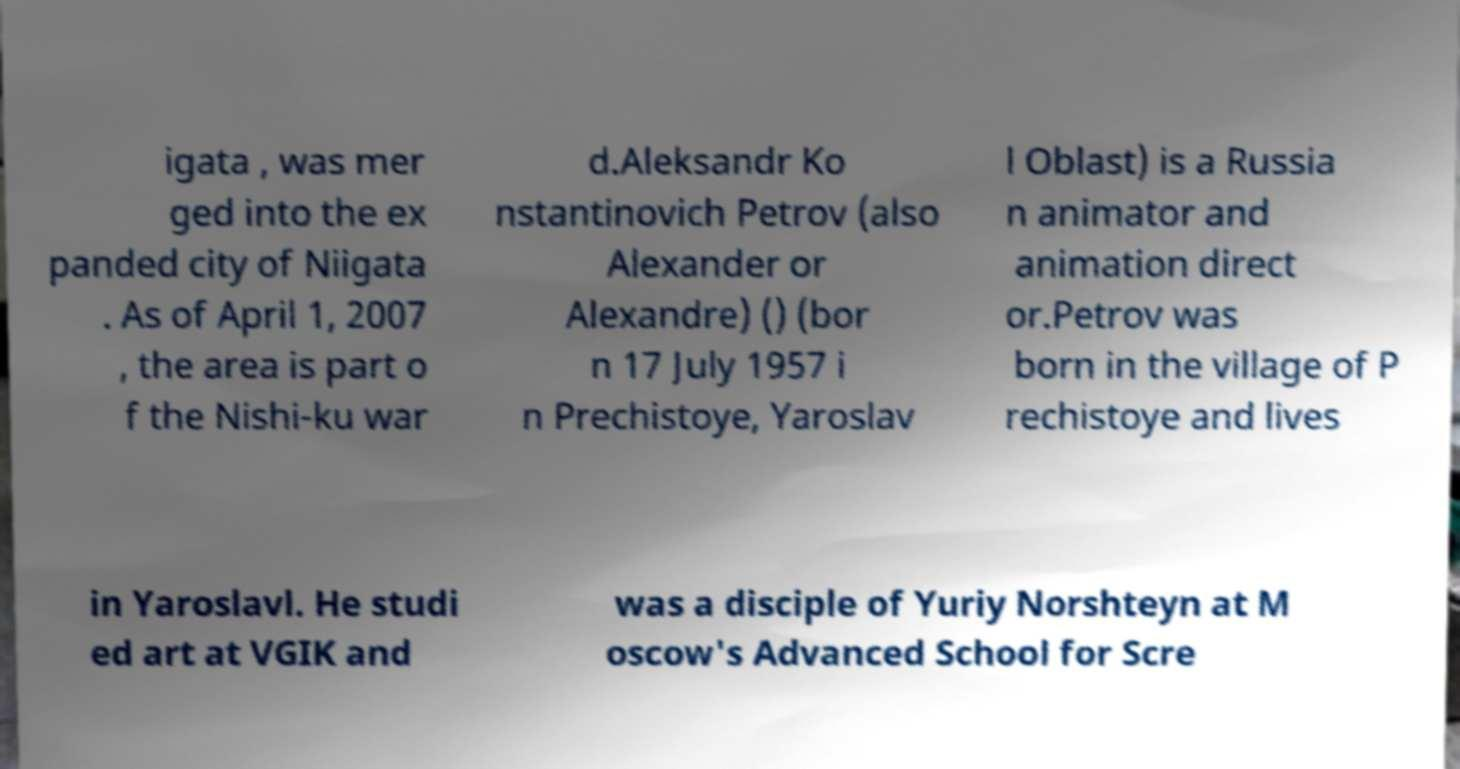What messages or text are displayed in this image? I need them in a readable, typed format. igata , was mer ged into the ex panded city of Niigata . As of April 1, 2007 , the area is part o f the Nishi-ku war d.Aleksandr Ko nstantinovich Petrov (also Alexander or Alexandre) () (bor n 17 July 1957 i n Prechistoye, Yaroslav l Oblast) is a Russia n animator and animation direct or.Petrov was born in the village of P rechistoye and lives in Yaroslavl. He studi ed art at VGIK and was a disciple of Yuriy Norshteyn at M oscow's Advanced School for Scre 